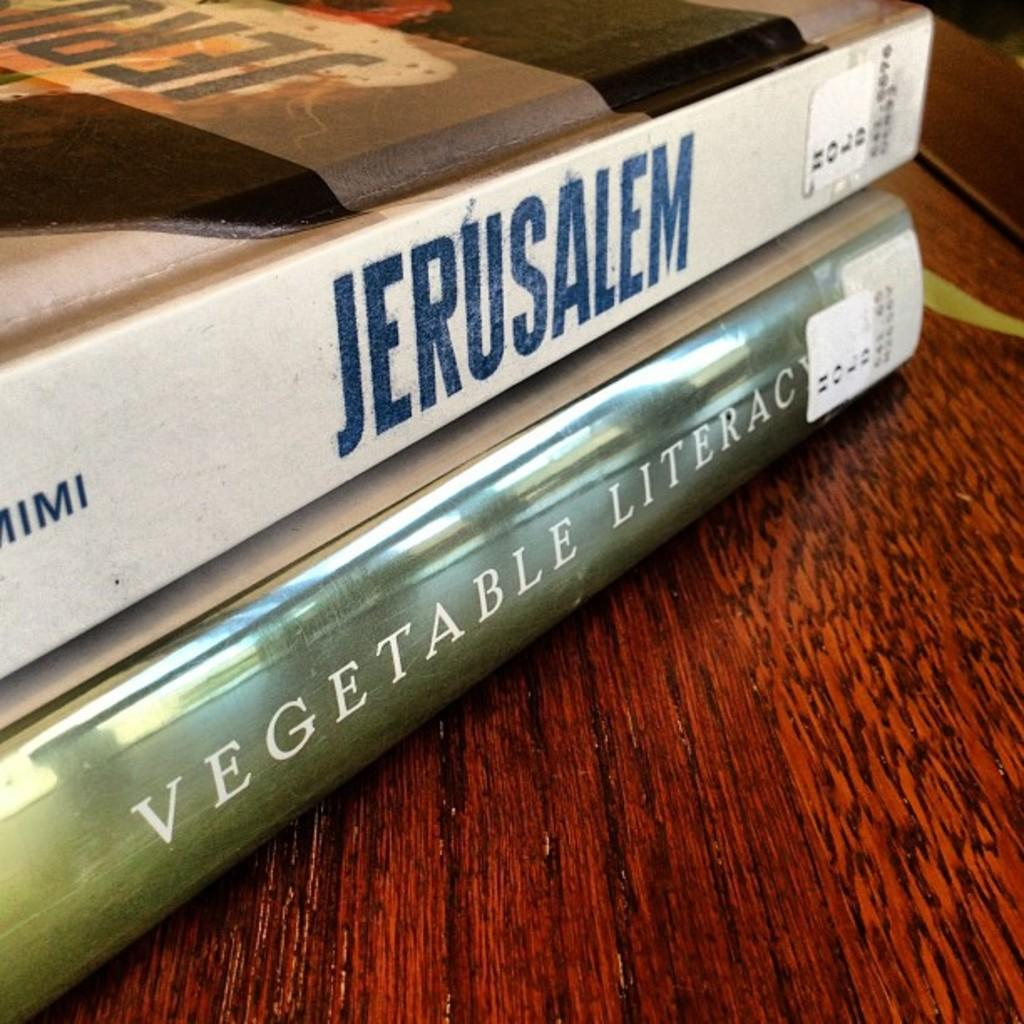<image>
Offer a succinct explanation of the picture presented. Two books called Jerusalem and Vegetable Literacy are on a wooden table. 